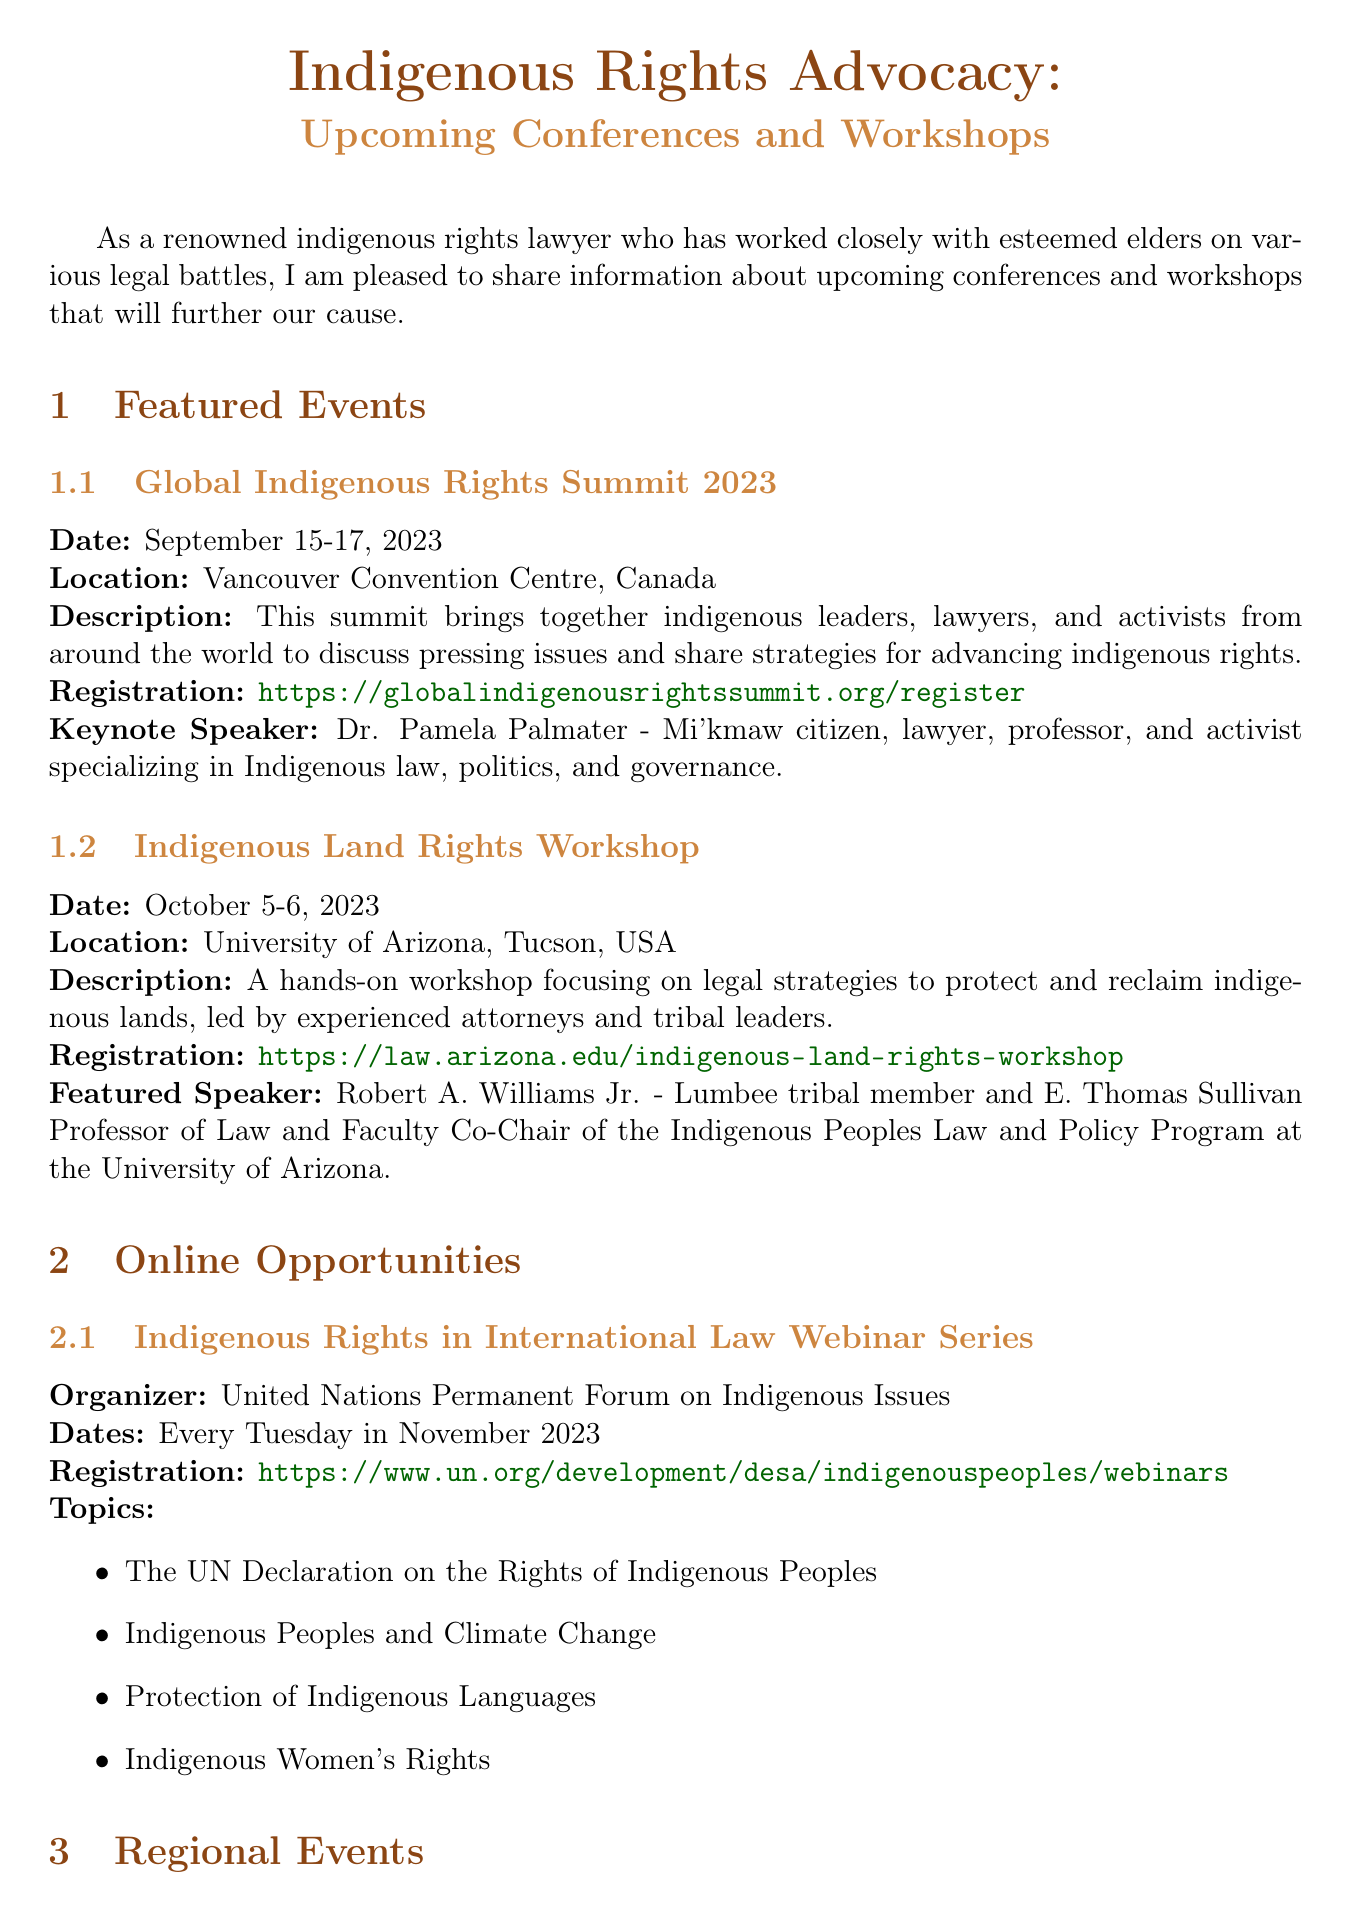What is the title of the newsletter? The title of the newsletter summarizes the content, which includes upcoming events related to indigenous rights advocacy.
Answer: Indigenous Rights Advocacy: Upcoming Conferences and Workshops When is the Global Indigenous Rights Summit taking place? The date of the summit is explicitly given in the document under featured events.
Answer: September 15-17, 2023 Who is the keynote speaker for the Australian Indigenous Rights Conference? The keynote speaker is mentioned, along with her credentials, in the regional events section.
Answer: Professor Megan Davis What is the main focus of the Indigenous Land Rights Workshop? The document provides a brief description of the workshop's objective under featured events.
Answer: Legal strategies to protect and reclaim indigenous lands How often is the Indigenous Rights in International Law Webinar Series held? The frequency of the webinars is stated in the online opportunities section.
Answer: Every Tuesday in November 2023 Which organization is sponsoring the webinar series? The sponsoring organization is listed at the beginning of the online opportunities section.
Answer: United Nations Permanent Forum on Indigenous Issues What resource is described as a practical guide for lawyers? The description under advocacy resources specifies what this resource provides for its users.
Answer: Indigenous Rights Advocacy Toolkit How many featured events are listed in the newsletter? By counting the events mentioned in the featured events section, we can ascertain this information.
Answer: Two What type of document is this? The content and structure, as well as the title, indicate the nature of the document.
Answer: Newsletter 